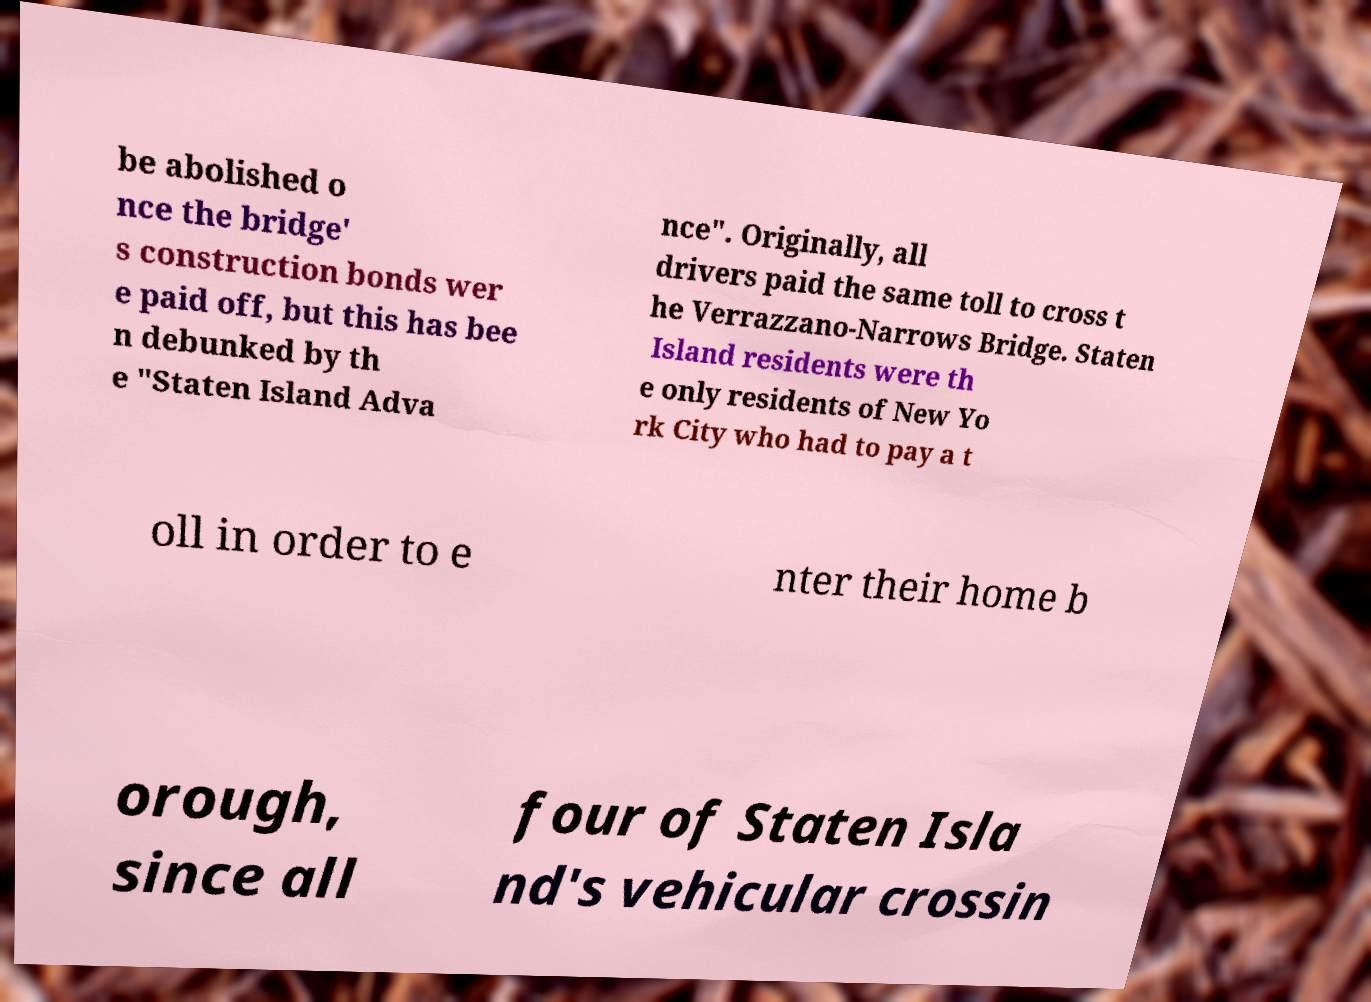Please identify and transcribe the text found in this image. be abolished o nce the bridge' s construction bonds wer e paid off, but this has bee n debunked by th e "Staten Island Adva nce". Originally, all drivers paid the same toll to cross t he Verrazzano-Narrows Bridge. Staten Island residents were th e only residents of New Yo rk City who had to pay a t oll in order to e nter their home b orough, since all four of Staten Isla nd's vehicular crossin 